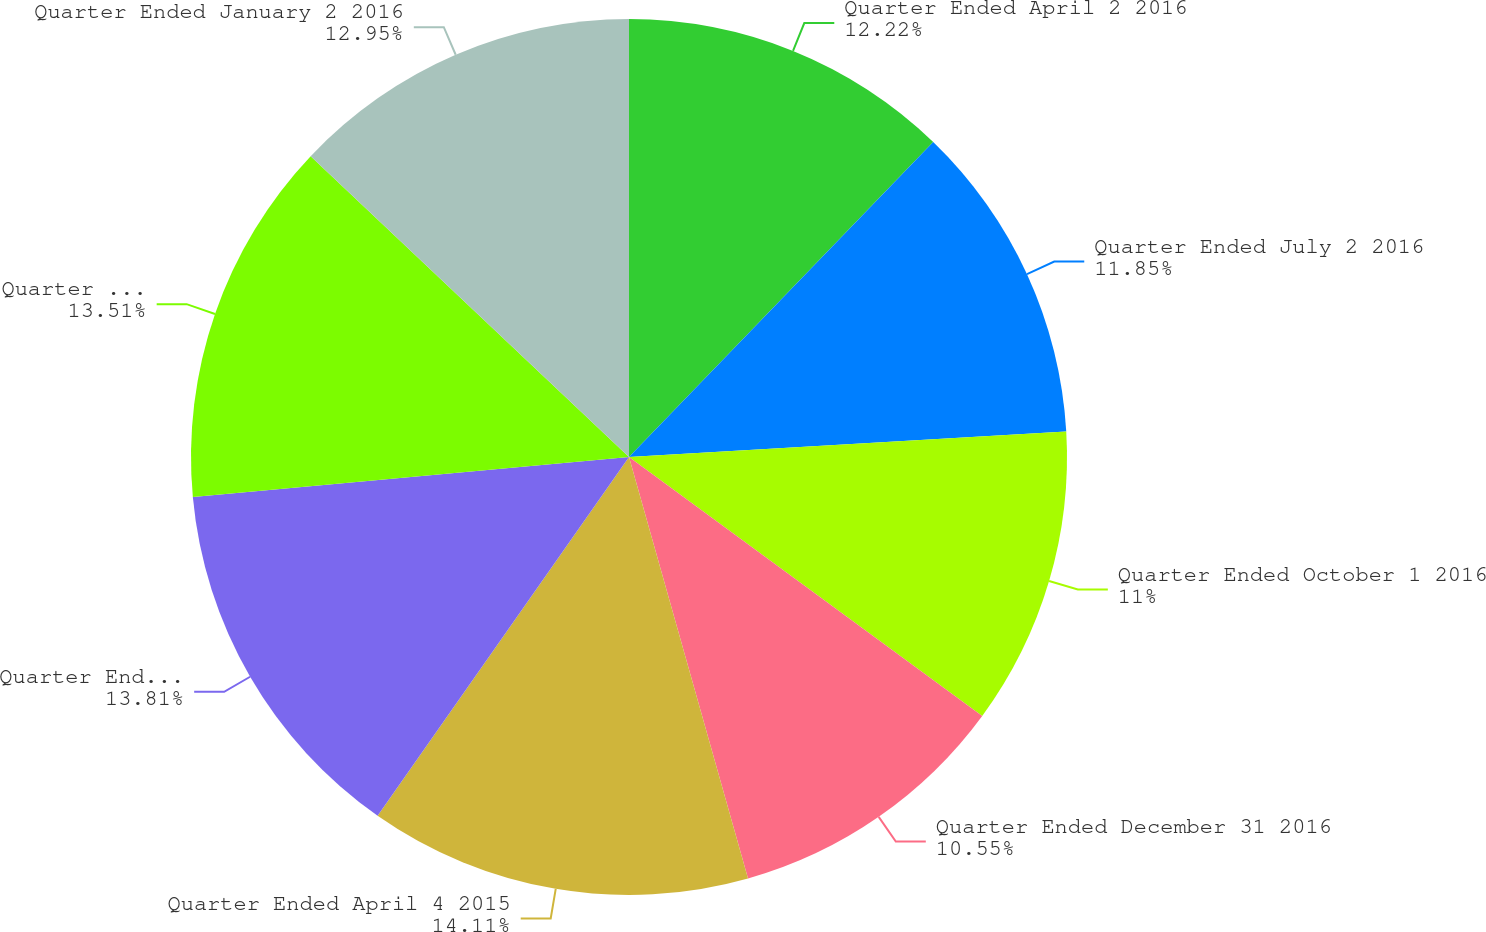Convert chart to OTSL. <chart><loc_0><loc_0><loc_500><loc_500><pie_chart><fcel>Quarter Ended April 2 2016<fcel>Quarter Ended July 2 2016<fcel>Quarter Ended October 1 2016<fcel>Quarter Ended December 31 2016<fcel>Quarter Ended April 4 2015<fcel>Quarter Ended July 4 2015<fcel>Quarter Ended October 3 2015<fcel>Quarter Ended January 2 2016<nl><fcel>12.22%<fcel>11.85%<fcel>11.0%<fcel>10.55%<fcel>14.11%<fcel>13.81%<fcel>13.51%<fcel>12.95%<nl></chart> 